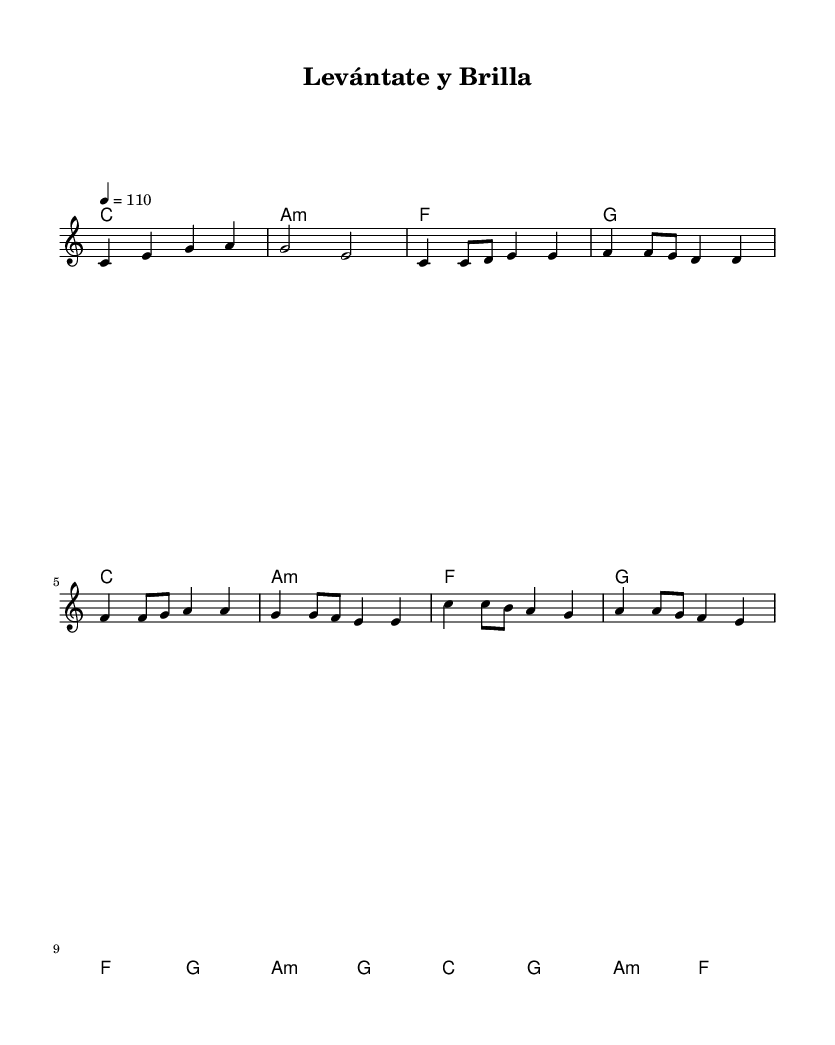What is the key signature of this music? The key signature is identified by the first element in the global section of the code, which indicates C major. C major has no sharps or flats.
Answer: C major What is the time signature of this music? The time signature is found in the same global section, as indicated by the value "4/4," specifying that there are four beats in each measure and the quarter note gets one beat.
Answer: 4/4 What is the tempo marking of this music? The tempo is specified in the global section as "4 = 110," which means the quarter note is to be played at 110 beats per minute.
Answer: 110 How many measures are in the chorus? The chorus is designated within the code and comprises eight measures, as calculated from the melody line where the chorus lyrics appear.
Answer: 8 What is the main theme of the chorus? The chorus emphasizes uplifting and motivational lyrics encouraging perseverance and strength, as suggested by the repeated phrase regarding rising and shining.
Answer: Levántate y brilla What type of mood is conveyed through the tempo and lyrics? The tempo of 110 beats per minute combined with the motivational lyrics suggests an upbeat and positive mood, characteristic of uplifting music intended to inspire listeners.
Answer: Uplifting What progression is used in the verses? The harmonic progression in the verses alternates between the chords C major, A minor, F major, and G major, which outlines a common pop structure that enhances the song’s hopeful message.
Answer: C, A minor, F, G 